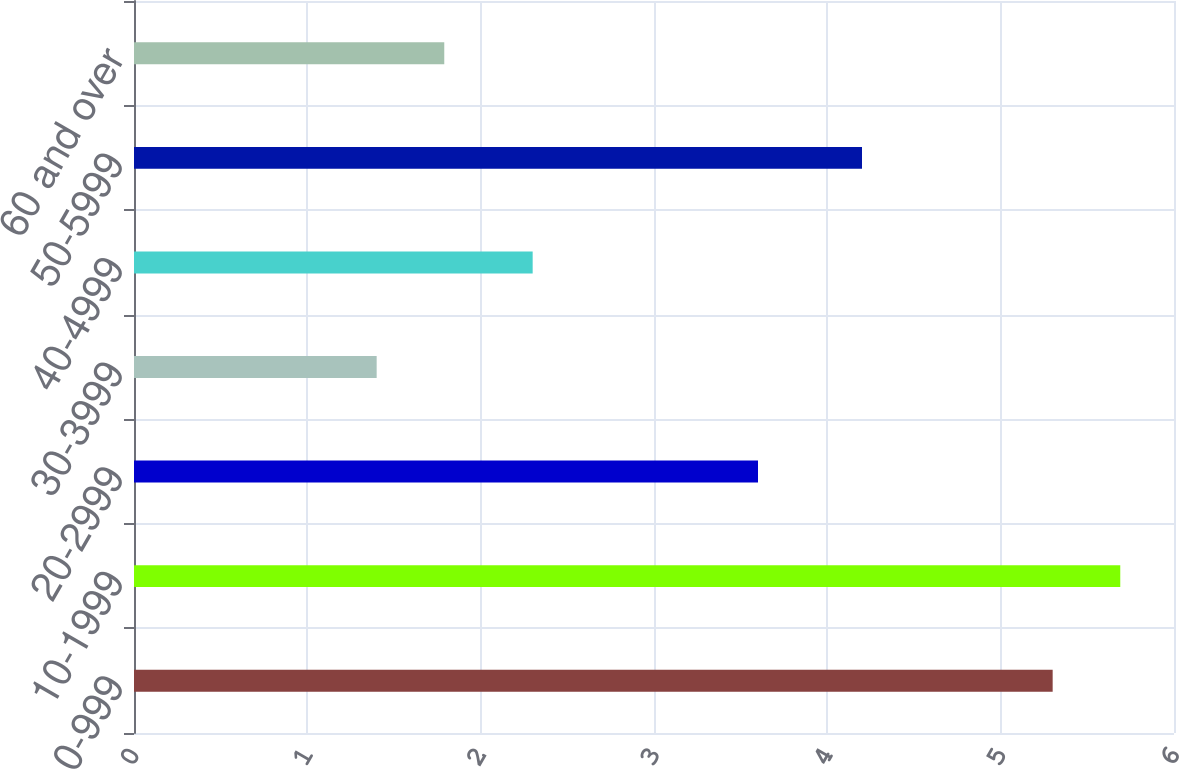<chart> <loc_0><loc_0><loc_500><loc_500><bar_chart><fcel>0-999<fcel>10-1999<fcel>20-2999<fcel>30-3999<fcel>40-4999<fcel>50-5999<fcel>60 and over<nl><fcel>5.3<fcel>5.69<fcel>3.6<fcel>1.4<fcel>2.3<fcel>4.2<fcel>1.79<nl></chart> 